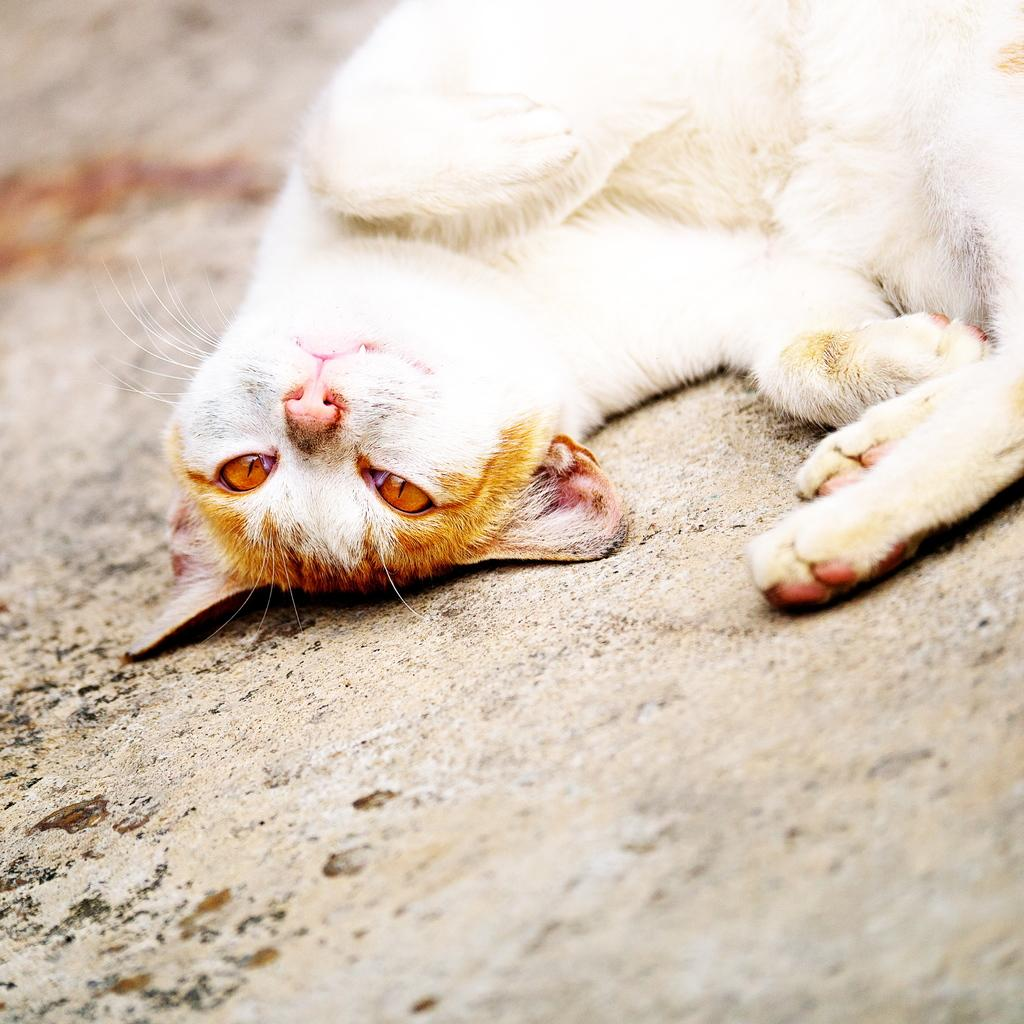What is the main subject in the center of the image? There is a cat in the center of the image. What can be seen at the bottom of the image? There is a walkway at the bottom of the image. Where is the stove located in the image? There is no stove present in the image. What is the plot of the story being told in the image? The image does not depict a story or plot; it simply shows a cat and a walkway. 